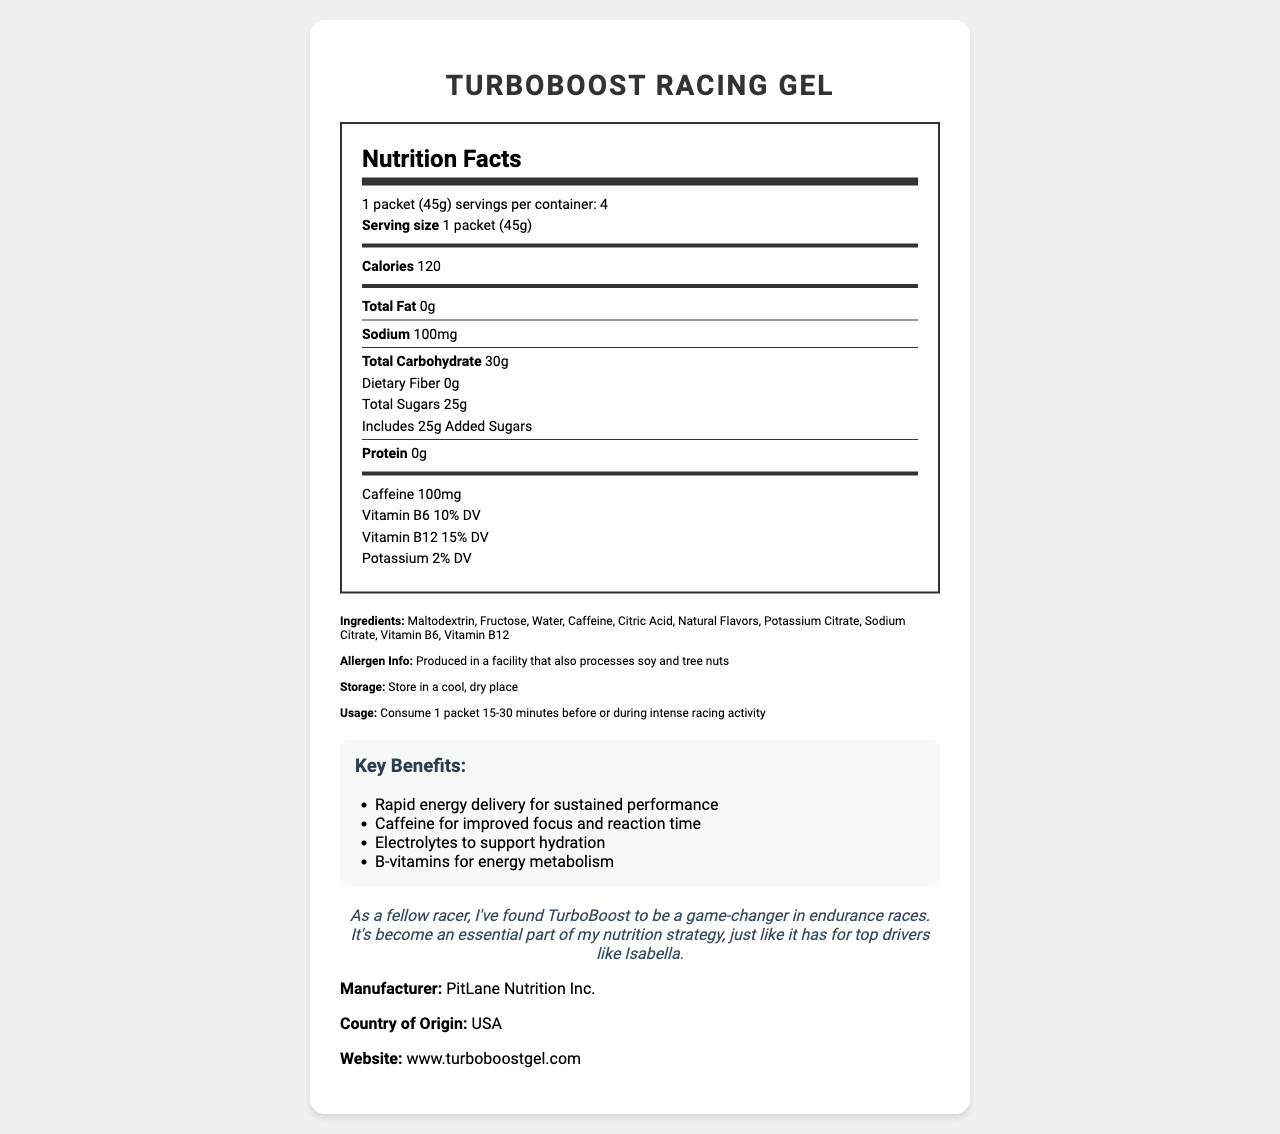What is the serving size of TurboBoost Racing Gel? The serving size is clearly stated as "1 packet (45g)" in the nutrition facts section.
Answer: 1 packet (45g) How many calories are there per serving? The amount of calories per serving is clearly indicated as 120 in the nutrition facts section.
Answer: 120 What is the total carbohydrate content per serving? The total carbohydrate content per serving is listed as 30g in the nutrition facts section.
Answer: 30g How much caffeine is in one serving of the gel? The caffeine content per serving is specified as 100mg in the nutrition facts section.
Answer: 100mg Name two vitamins included in the TurboBoost Racing Gel. The vitamins listed in the nutrition facts section are Vitamin B6 and Vitamin B12.
Answer: Vitamin B6, Vitamin B12 What is the recommended time to consume TurboBoost Racing Gel? The usage instructions specify that the gel should be consumed 15-30 minutes before or during intense racing activity.
Answer: 15-30 minutes before or during intense racing activity Which of the following is NOT an ingredient in TurboBoost Racing Gel? A. Maltodextrin B. Sugar C. Citric Acid D. Fructose The ingredients listed include Maltodextrin, Fructose, Citric Acid, but not "Sugar" specifically.
Answer: B Where should you store TurboBoost Racing Gel? A. In the refrigerator B. At room temperature C. In a cool, dry place D. In a warm place The storage instructions say to store the gel in a cool, dry place.
Answer: C Does TurboBoost Racing Gel contain any protein? The nutrition facts label lists the protein content as 0g.
Answer: No Is this product suitable for someone who avoids soy and tree nuts? The allergen information states that the gel is produced in a facility that processes soy and tree nuts.
Answer: No Provide a brief summary of the TurboBoost Racing Gel product. The summary consolidates the key details about the product's benefits, nutritional contents, usage guidelines, and other essential information presented in the document.
Answer: TurboBoost Racing Gel is a performance-enhancing gel for racers, offering a quick energy boost with fast-absorbing sugars and caffeine. It contains 120 calories, 30g of carbohydrates, and 100mg of caffeine per serving. The product includes vitamins B6 and B12 and is designed to support hydration and energy metabolism. Usage recommendations, storage guidelines, and allergen information are provided. How many servings are in one container of TurboBoost Racing Gel? The document lists that there are 4 servings per container.
Answer: 4 What percentage of the daily value of Vitamin B12 does one serving of TurboBoost Racing Gel provide? The nutrition facts section states that one serving provides 15% of the daily value of Vitamin B12.
Answer: 15% DV What is the primary purpose of TurboBoost Racing Gel according to the product description? The product description mentions that the gel is formulated to provide a quick energy boost with fast-absorbing carbohydrates and caffeine for focus during crucial laps.
Answer: To provide a quick energy boost and help maintain focus during critical laps How much sodium is in each serving? The sodium content per serving is listed as 100mg in the nutrition facts section.
Answer: 100mg Is TurboBoost Racing Gel a product of PitLane Nutrition Inc.? The manufacturer is listed as PitLane Nutrition Inc. in the document.
Answer: Yes Who endorses TurboBoost Racing Gel in the testimonial? The testimonial is given by a fellow racer who praises the product for endurance races and states that it's essential for top drivers like Isabella.
Answer: A fellow racer who uses the product in endurance races and mentions that top drivers like Isabella also find it essential 